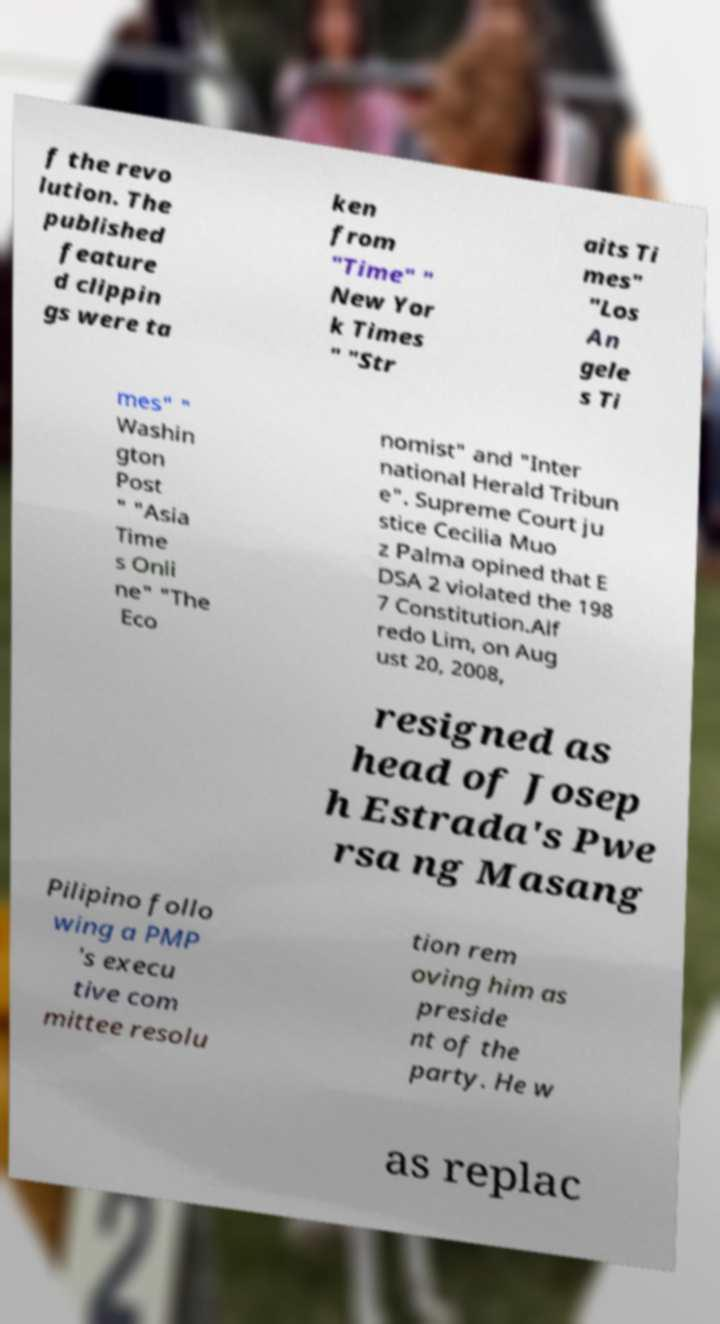Please read and relay the text visible in this image. What does it say? f the revo lution. The published feature d clippin gs were ta ken from "Time" " New Yor k Times " "Str aits Ti mes" "Los An gele s Ti mes" " Washin gton Post " "Asia Time s Onli ne" "The Eco nomist" and "Inter national Herald Tribun e". Supreme Court ju stice Cecilia Muo z Palma opined that E DSA 2 violated the 198 7 Constitution.Alf redo Lim, on Aug ust 20, 2008, resigned as head of Josep h Estrada's Pwe rsa ng Masang Pilipino follo wing a PMP 's execu tive com mittee resolu tion rem oving him as preside nt of the party. He w as replac 